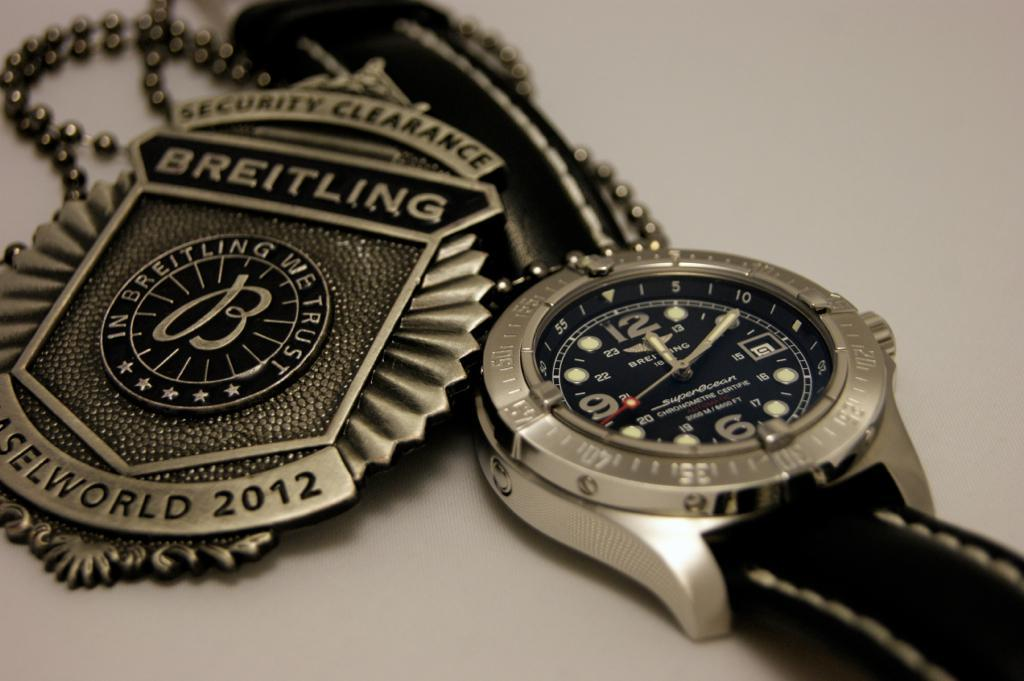<image>
Share a concise interpretation of the image provided. A Breitling security clearance badge sits next to a watch. 